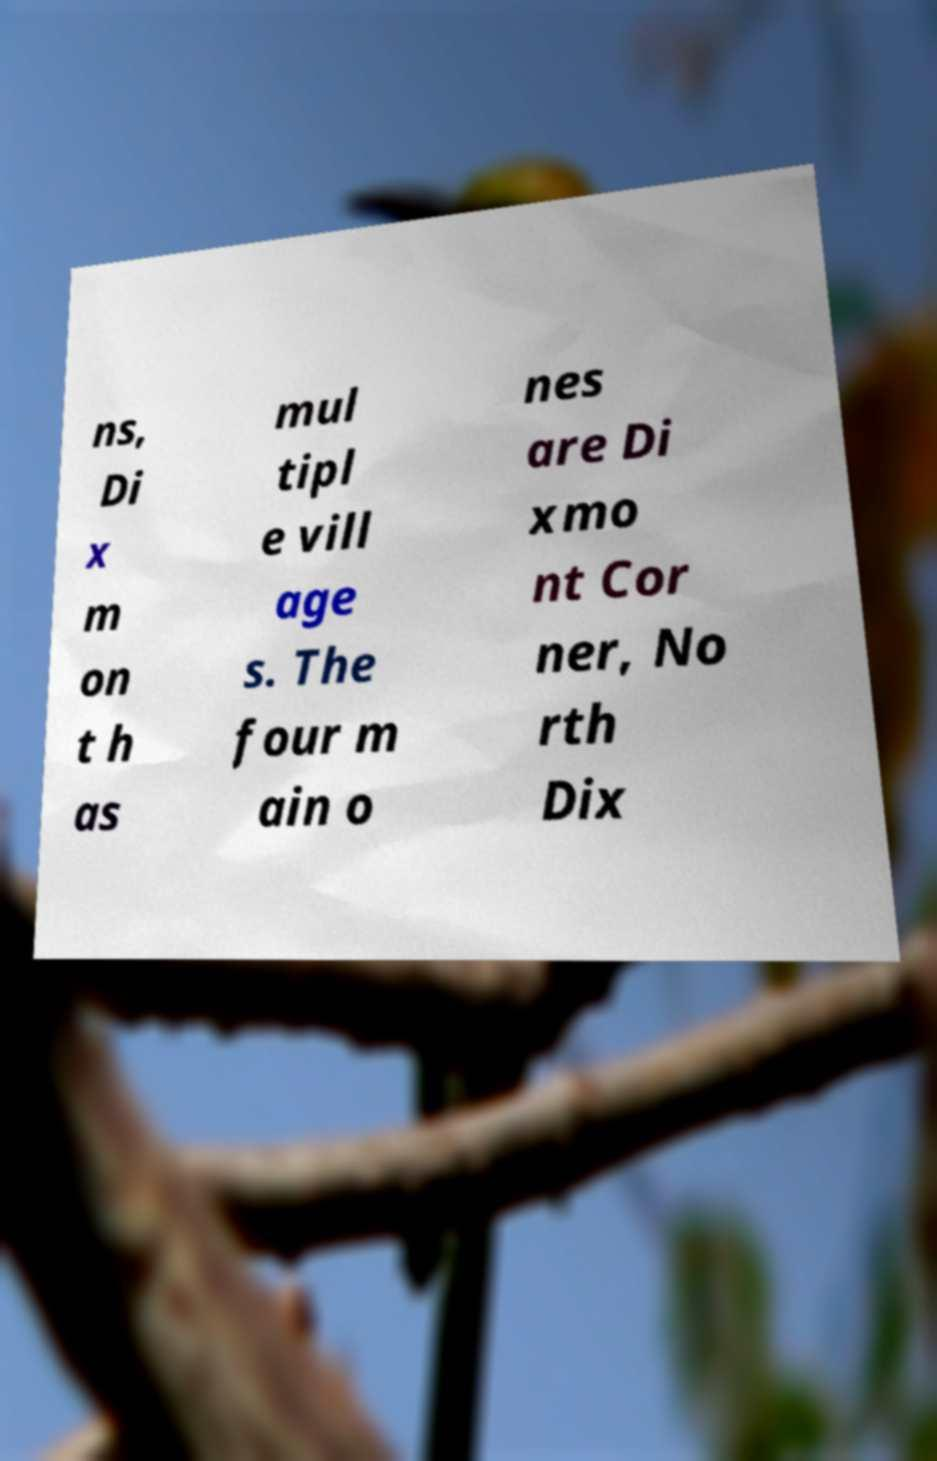Could you assist in decoding the text presented in this image and type it out clearly? ns, Di x m on t h as mul tipl e vill age s. The four m ain o nes are Di xmo nt Cor ner, No rth Dix 